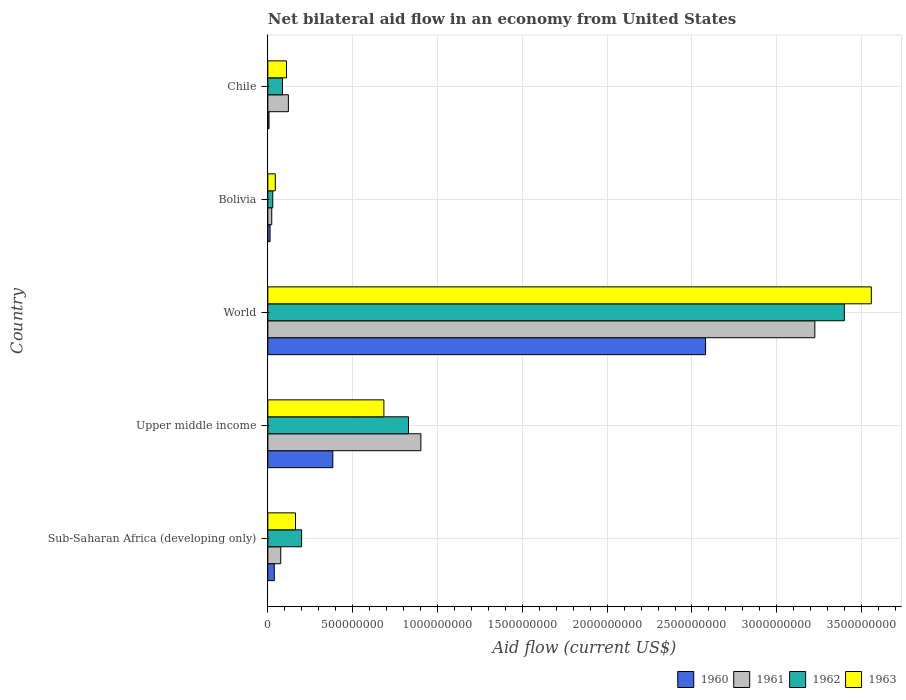How many groups of bars are there?
Keep it short and to the point. 5. Are the number of bars on each tick of the Y-axis equal?
Your answer should be compact. Yes. What is the label of the 3rd group of bars from the top?
Your answer should be very brief. World. In how many cases, is the number of bars for a given country not equal to the number of legend labels?
Give a very brief answer. 0. What is the net bilateral aid flow in 1963 in Upper middle income?
Your answer should be compact. 6.84e+08. Across all countries, what is the maximum net bilateral aid flow in 1960?
Give a very brief answer. 2.58e+09. What is the total net bilateral aid flow in 1960 in the graph?
Ensure brevity in your answer.  3.02e+09. What is the difference between the net bilateral aid flow in 1961 in Bolivia and that in Chile?
Make the answer very short. -9.80e+07. What is the difference between the net bilateral aid flow in 1960 in Bolivia and the net bilateral aid flow in 1961 in Sub-Saharan Africa (developing only)?
Your response must be concise. -6.30e+07. What is the average net bilateral aid flow in 1960 per country?
Give a very brief answer. 6.04e+08. What is the difference between the net bilateral aid flow in 1960 and net bilateral aid flow in 1963 in Sub-Saharan Africa (developing only)?
Provide a succinct answer. -1.25e+08. What is the ratio of the net bilateral aid flow in 1960 in Chile to that in World?
Provide a succinct answer. 0. Is the net bilateral aid flow in 1960 in Chile less than that in Upper middle income?
Offer a terse response. Yes. Is the difference between the net bilateral aid flow in 1960 in Sub-Saharan Africa (developing only) and Upper middle income greater than the difference between the net bilateral aid flow in 1963 in Sub-Saharan Africa (developing only) and Upper middle income?
Your response must be concise. Yes. What is the difference between the highest and the second highest net bilateral aid flow in 1961?
Your response must be concise. 2.32e+09. What is the difference between the highest and the lowest net bilateral aid flow in 1960?
Keep it short and to the point. 2.57e+09. In how many countries, is the net bilateral aid flow in 1960 greater than the average net bilateral aid flow in 1960 taken over all countries?
Give a very brief answer. 1. Is it the case that in every country, the sum of the net bilateral aid flow in 1962 and net bilateral aid flow in 1963 is greater than the sum of net bilateral aid flow in 1961 and net bilateral aid flow in 1960?
Ensure brevity in your answer.  No. Is it the case that in every country, the sum of the net bilateral aid flow in 1960 and net bilateral aid flow in 1963 is greater than the net bilateral aid flow in 1962?
Make the answer very short. Yes. How many bars are there?
Your answer should be compact. 20. Are all the bars in the graph horizontal?
Your response must be concise. Yes. Does the graph contain any zero values?
Ensure brevity in your answer.  No. Does the graph contain grids?
Offer a very short reply. Yes. How many legend labels are there?
Offer a very short reply. 4. How are the legend labels stacked?
Offer a terse response. Horizontal. What is the title of the graph?
Your response must be concise. Net bilateral aid flow in an economy from United States. Does "1962" appear as one of the legend labels in the graph?
Keep it short and to the point. Yes. What is the label or title of the Y-axis?
Give a very brief answer. Country. What is the Aid flow (current US$) of 1960 in Sub-Saharan Africa (developing only)?
Provide a short and direct response. 3.80e+07. What is the Aid flow (current US$) of 1961 in Sub-Saharan Africa (developing only)?
Offer a very short reply. 7.60e+07. What is the Aid flow (current US$) of 1962 in Sub-Saharan Africa (developing only)?
Your response must be concise. 1.99e+08. What is the Aid flow (current US$) in 1963 in Sub-Saharan Africa (developing only)?
Ensure brevity in your answer.  1.63e+08. What is the Aid flow (current US$) of 1960 in Upper middle income?
Offer a very short reply. 3.83e+08. What is the Aid flow (current US$) of 1961 in Upper middle income?
Offer a terse response. 9.02e+08. What is the Aid flow (current US$) of 1962 in Upper middle income?
Provide a short and direct response. 8.29e+08. What is the Aid flow (current US$) in 1963 in Upper middle income?
Give a very brief answer. 6.84e+08. What is the Aid flow (current US$) of 1960 in World?
Your response must be concise. 2.58e+09. What is the Aid flow (current US$) of 1961 in World?
Make the answer very short. 3.22e+09. What is the Aid flow (current US$) of 1962 in World?
Your response must be concise. 3.40e+09. What is the Aid flow (current US$) in 1963 in World?
Your response must be concise. 3.56e+09. What is the Aid flow (current US$) of 1960 in Bolivia?
Provide a short and direct response. 1.30e+07. What is the Aid flow (current US$) of 1961 in Bolivia?
Your answer should be very brief. 2.30e+07. What is the Aid flow (current US$) of 1962 in Bolivia?
Ensure brevity in your answer.  2.90e+07. What is the Aid flow (current US$) in 1963 in Bolivia?
Provide a short and direct response. 4.40e+07. What is the Aid flow (current US$) of 1960 in Chile?
Provide a short and direct response. 7.00e+06. What is the Aid flow (current US$) of 1961 in Chile?
Provide a short and direct response. 1.21e+08. What is the Aid flow (current US$) in 1962 in Chile?
Keep it short and to the point. 8.60e+07. What is the Aid flow (current US$) of 1963 in Chile?
Provide a succinct answer. 1.10e+08. Across all countries, what is the maximum Aid flow (current US$) of 1960?
Keep it short and to the point. 2.58e+09. Across all countries, what is the maximum Aid flow (current US$) in 1961?
Give a very brief answer. 3.22e+09. Across all countries, what is the maximum Aid flow (current US$) in 1962?
Provide a short and direct response. 3.40e+09. Across all countries, what is the maximum Aid flow (current US$) of 1963?
Provide a short and direct response. 3.56e+09. Across all countries, what is the minimum Aid flow (current US$) of 1961?
Keep it short and to the point. 2.30e+07. Across all countries, what is the minimum Aid flow (current US$) in 1962?
Offer a terse response. 2.90e+07. Across all countries, what is the minimum Aid flow (current US$) in 1963?
Provide a short and direct response. 4.40e+07. What is the total Aid flow (current US$) in 1960 in the graph?
Your response must be concise. 3.02e+09. What is the total Aid flow (current US$) in 1961 in the graph?
Provide a succinct answer. 4.35e+09. What is the total Aid flow (current US$) of 1962 in the graph?
Make the answer very short. 4.54e+09. What is the total Aid flow (current US$) of 1963 in the graph?
Your answer should be very brief. 4.56e+09. What is the difference between the Aid flow (current US$) of 1960 in Sub-Saharan Africa (developing only) and that in Upper middle income?
Ensure brevity in your answer.  -3.45e+08. What is the difference between the Aid flow (current US$) of 1961 in Sub-Saharan Africa (developing only) and that in Upper middle income?
Your response must be concise. -8.26e+08. What is the difference between the Aid flow (current US$) of 1962 in Sub-Saharan Africa (developing only) and that in Upper middle income?
Your response must be concise. -6.30e+08. What is the difference between the Aid flow (current US$) in 1963 in Sub-Saharan Africa (developing only) and that in Upper middle income?
Keep it short and to the point. -5.21e+08. What is the difference between the Aid flow (current US$) of 1960 in Sub-Saharan Africa (developing only) and that in World?
Ensure brevity in your answer.  -2.54e+09. What is the difference between the Aid flow (current US$) of 1961 in Sub-Saharan Africa (developing only) and that in World?
Make the answer very short. -3.15e+09. What is the difference between the Aid flow (current US$) in 1962 in Sub-Saharan Africa (developing only) and that in World?
Your answer should be compact. -3.20e+09. What is the difference between the Aid flow (current US$) in 1963 in Sub-Saharan Africa (developing only) and that in World?
Offer a very short reply. -3.39e+09. What is the difference between the Aid flow (current US$) in 1960 in Sub-Saharan Africa (developing only) and that in Bolivia?
Make the answer very short. 2.50e+07. What is the difference between the Aid flow (current US$) of 1961 in Sub-Saharan Africa (developing only) and that in Bolivia?
Keep it short and to the point. 5.30e+07. What is the difference between the Aid flow (current US$) in 1962 in Sub-Saharan Africa (developing only) and that in Bolivia?
Provide a succinct answer. 1.70e+08. What is the difference between the Aid flow (current US$) of 1963 in Sub-Saharan Africa (developing only) and that in Bolivia?
Your response must be concise. 1.19e+08. What is the difference between the Aid flow (current US$) of 1960 in Sub-Saharan Africa (developing only) and that in Chile?
Ensure brevity in your answer.  3.10e+07. What is the difference between the Aid flow (current US$) in 1961 in Sub-Saharan Africa (developing only) and that in Chile?
Ensure brevity in your answer.  -4.50e+07. What is the difference between the Aid flow (current US$) in 1962 in Sub-Saharan Africa (developing only) and that in Chile?
Your answer should be very brief. 1.13e+08. What is the difference between the Aid flow (current US$) of 1963 in Sub-Saharan Africa (developing only) and that in Chile?
Your answer should be very brief. 5.30e+07. What is the difference between the Aid flow (current US$) of 1960 in Upper middle income and that in World?
Your answer should be compact. -2.20e+09. What is the difference between the Aid flow (current US$) of 1961 in Upper middle income and that in World?
Ensure brevity in your answer.  -2.32e+09. What is the difference between the Aid flow (current US$) in 1962 in Upper middle income and that in World?
Your answer should be very brief. -2.57e+09. What is the difference between the Aid flow (current US$) in 1963 in Upper middle income and that in World?
Give a very brief answer. -2.87e+09. What is the difference between the Aid flow (current US$) in 1960 in Upper middle income and that in Bolivia?
Offer a terse response. 3.70e+08. What is the difference between the Aid flow (current US$) of 1961 in Upper middle income and that in Bolivia?
Your response must be concise. 8.79e+08. What is the difference between the Aid flow (current US$) of 1962 in Upper middle income and that in Bolivia?
Make the answer very short. 8.00e+08. What is the difference between the Aid flow (current US$) of 1963 in Upper middle income and that in Bolivia?
Provide a succinct answer. 6.40e+08. What is the difference between the Aid flow (current US$) of 1960 in Upper middle income and that in Chile?
Your response must be concise. 3.76e+08. What is the difference between the Aid flow (current US$) of 1961 in Upper middle income and that in Chile?
Offer a terse response. 7.81e+08. What is the difference between the Aid flow (current US$) of 1962 in Upper middle income and that in Chile?
Give a very brief answer. 7.43e+08. What is the difference between the Aid flow (current US$) of 1963 in Upper middle income and that in Chile?
Give a very brief answer. 5.74e+08. What is the difference between the Aid flow (current US$) in 1960 in World and that in Bolivia?
Offer a very short reply. 2.57e+09. What is the difference between the Aid flow (current US$) of 1961 in World and that in Bolivia?
Provide a short and direct response. 3.20e+09. What is the difference between the Aid flow (current US$) of 1962 in World and that in Bolivia?
Your response must be concise. 3.37e+09. What is the difference between the Aid flow (current US$) of 1963 in World and that in Bolivia?
Provide a short and direct response. 3.51e+09. What is the difference between the Aid flow (current US$) of 1960 in World and that in Chile?
Ensure brevity in your answer.  2.57e+09. What is the difference between the Aid flow (current US$) in 1961 in World and that in Chile?
Make the answer very short. 3.10e+09. What is the difference between the Aid flow (current US$) of 1962 in World and that in Chile?
Your answer should be very brief. 3.31e+09. What is the difference between the Aid flow (current US$) in 1963 in World and that in Chile?
Your response must be concise. 3.45e+09. What is the difference between the Aid flow (current US$) of 1960 in Bolivia and that in Chile?
Offer a terse response. 6.00e+06. What is the difference between the Aid flow (current US$) in 1961 in Bolivia and that in Chile?
Keep it short and to the point. -9.80e+07. What is the difference between the Aid flow (current US$) of 1962 in Bolivia and that in Chile?
Offer a very short reply. -5.70e+07. What is the difference between the Aid flow (current US$) of 1963 in Bolivia and that in Chile?
Offer a very short reply. -6.60e+07. What is the difference between the Aid flow (current US$) of 1960 in Sub-Saharan Africa (developing only) and the Aid flow (current US$) of 1961 in Upper middle income?
Offer a terse response. -8.64e+08. What is the difference between the Aid flow (current US$) of 1960 in Sub-Saharan Africa (developing only) and the Aid flow (current US$) of 1962 in Upper middle income?
Keep it short and to the point. -7.91e+08. What is the difference between the Aid flow (current US$) of 1960 in Sub-Saharan Africa (developing only) and the Aid flow (current US$) of 1963 in Upper middle income?
Offer a terse response. -6.46e+08. What is the difference between the Aid flow (current US$) in 1961 in Sub-Saharan Africa (developing only) and the Aid flow (current US$) in 1962 in Upper middle income?
Provide a short and direct response. -7.53e+08. What is the difference between the Aid flow (current US$) in 1961 in Sub-Saharan Africa (developing only) and the Aid flow (current US$) in 1963 in Upper middle income?
Your answer should be compact. -6.08e+08. What is the difference between the Aid flow (current US$) in 1962 in Sub-Saharan Africa (developing only) and the Aid flow (current US$) in 1963 in Upper middle income?
Provide a short and direct response. -4.85e+08. What is the difference between the Aid flow (current US$) of 1960 in Sub-Saharan Africa (developing only) and the Aid flow (current US$) of 1961 in World?
Your answer should be very brief. -3.19e+09. What is the difference between the Aid flow (current US$) in 1960 in Sub-Saharan Africa (developing only) and the Aid flow (current US$) in 1962 in World?
Your response must be concise. -3.36e+09. What is the difference between the Aid flow (current US$) of 1960 in Sub-Saharan Africa (developing only) and the Aid flow (current US$) of 1963 in World?
Offer a very short reply. -3.52e+09. What is the difference between the Aid flow (current US$) of 1961 in Sub-Saharan Africa (developing only) and the Aid flow (current US$) of 1962 in World?
Ensure brevity in your answer.  -3.32e+09. What is the difference between the Aid flow (current US$) of 1961 in Sub-Saharan Africa (developing only) and the Aid flow (current US$) of 1963 in World?
Provide a succinct answer. -3.48e+09. What is the difference between the Aid flow (current US$) of 1962 in Sub-Saharan Africa (developing only) and the Aid flow (current US$) of 1963 in World?
Provide a succinct answer. -3.36e+09. What is the difference between the Aid flow (current US$) in 1960 in Sub-Saharan Africa (developing only) and the Aid flow (current US$) in 1961 in Bolivia?
Give a very brief answer. 1.50e+07. What is the difference between the Aid flow (current US$) in 1960 in Sub-Saharan Africa (developing only) and the Aid flow (current US$) in 1962 in Bolivia?
Your answer should be very brief. 9.00e+06. What is the difference between the Aid flow (current US$) of 1960 in Sub-Saharan Africa (developing only) and the Aid flow (current US$) of 1963 in Bolivia?
Keep it short and to the point. -6.00e+06. What is the difference between the Aid flow (current US$) in 1961 in Sub-Saharan Africa (developing only) and the Aid flow (current US$) in 1962 in Bolivia?
Your response must be concise. 4.70e+07. What is the difference between the Aid flow (current US$) of 1961 in Sub-Saharan Africa (developing only) and the Aid flow (current US$) of 1963 in Bolivia?
Make the answer very short. 3.20e+07. What is the difference between the Aid flow (current US$) of 1962 in Sub-Saharan Africa (developing only) and the Aid flow (current US$) of 1963 in Bolivia?
Make the answer very short. 1.55e+08. What is the difference between the Aid flow (current US$) of 1960 in Sub-Saharan Africa (developing only) and the Aid flow (current US$) of 1961 in Chile?
Your response must be concise. -8.30e+07. What is the difference between the Aid flow (current US$) of 1960 in Sub-Saharan Africa (developing only) and the Aid flow (current US$) of 1962 in Chile?
Offer a very short reply. -4.80e+07. What is the difference between the Aid flow (current US$) in 1960 in Sub-Saharan Africa (developing only) and the Aid flow (current US$) in 1963 in Chile?
Your response must be concise. -7.20e+07. What is the difference between the Aid flow (current US$) in 1961 in Sub-Saharan Africa (developing only) and the Aid flow (current US$) in 1962 in Chile?
Provide a succinct answer. -1.00e+07. What is the difference between the Aid flow (current US$) in 1961 in Sub-Saharan Africa (developing only) and the Aid flow (current US$) in 1963 in Chile?
Offer a very short reply. -3.40e+07. What is the difference between the Aid flow (current US$) of 1962 in Sub-Saharan Africa (developing only) and the Aid flow (current US$) of 1963 in Chile?
Offer a very short reply. 8.90e+07. What is the difference between the Aid flow (current US$) in 1960 in Upper middle income and the Aid flow (current US$) in 1961 in World?
Provide a succinct answer. -2.84e+09. What is the difference between the Aid flow (current US$) in 1960 in Upper middle income and the Aid flow (current US$) in 1962 in World?
Keep it short and to the point. -3.02e+09. What is the difference between the Aid flow (current US$) in 1960 in Upper middle income and the Aid flow (current US$) in 1963 in World?
Your response must be concise. -3.17e+09. What is the difference between the Aid flow (current US$) of 1961 in Upper middle income and the Aid flow (current US$) of 1962 in World?
Ensure brevity in your answer.  -2.50e+09. What is the difference between the Aid flow (current US$) of 1961 in Upper middle income and the Aid flow (current US$) of 1963 in World?
Offer a very short reply. -2.66e+09. What is the difference between the Aid flow (current US$) of 1962 in Upper middle income and the Aid flow (current US$) of 1963 in World?
Keep it short and to the point. -2.73e+09. What is the difference between the Aid flow (current US$) of 1960 in Upper middle income and the Aid flow (current US$) of 1961 in Bolivia?
Your answer should be very brief. 3.60e+08. What is the difference between the Aid flow (current US$) of 1960 in Upper middle income and the Aid flow (current US$) of 1962 in Bolivia?
Give a very brief answer. 3.54e+08. What is the difference between the Aid flow (current US$) in 1960 in Upper middle income and the Aid flow (current US$) in 1963 in Bolivia?
Provide a short and direct response. 3.39e+08. What is the difference between the Aid flow (current US$) in 1961 in Upper middle income and the Aid flow (current US$) in 1962 in Bolivia?
Your answer should be compact. 8.73e+08. What is the difference between the Aid flow (current US$) of 1961 in Upper middle income and the Aid flow (current US$) of 1963 in Bolivia?
Keep it short and to the point. 8.58e+08. What is the difference between the Aid flow (current US$) of 1962 in Upper middle income and the Aid flow (current US$) of 1963 in Bolivia?
Your answer should be very brief. 7.85e+08. What is the difference between the Aid flow (current US$) in 1960 in Upper middle income and the Aid flow (current US$) in 1961 in Chile?
Give a very brief answer. 2.62e+08. What is the difference between the Aid flow (current US$) in 1960 in Upper middle income and the Aid flow (current US$) in 1962 in Chile?
Provide a short and direct response. 2.97e+08. What is the difference between the Aid flow (current US$) of 1960 in Upper middle income and the Aid flow (current US$) of 1963 in Chile?
Offer a terse response. 2.73e+08. What is the difference between the Aid flow (current US$) in 1961 in Upper middle income and the Aid flow (current US$) in 1962 in Chile?
Your response must be concise. 8.16e+08. What is the difference between the Aid flow (current US$) of 1961 in Upper middle income and the Aid flow (current US$) of 1963 in Chile?
Ensure brevity in your answer.  7.92e+08. What is the difference between the Aid flow (current US$) of 1962 in Upper middle income and the Aid flow (current US$) of 1963 in Chile?
Your answer should be very brief. 7.19e+08. What is the difference between the Aid flow (current US$) of 1960 in World and the Aid flow (current US$) of 1961 in Bolivia?
Your answer should be compact. 2.56e+09. What is the difference between the Aid flow (current US$) of 1960 in World and the Aid flow (current US$) of 1962 in Bolivia?
Offer a very short reply. 2.55e+09. What is the difference between the Aid flow (current US$) of 1960 in World and the Aid flow (current US$) of 1963 in Bolivia?
Your answer should be very brief. 2.54e+09. What is the difference between the Aid flow (current US$) of 1961 in World and the Aid flow (current US$) of 1962 in Bolivia?
Your answer should be very brief. 3.20e+09. What is the difference between the Aid flow (current US$) in 1961 in World and the Aid flow (current US$) in 1963 in Bolivia?
Provide a short and direct response. 3.18e+09. What is the difference between the Aid flow (current US$) of 1962 in World and the Aid flow (current US$) of 1963 in Bolivia?
Provide a short and direct response. 3.35e+09. What is the difference between the Aid flow (current US$) of 1960 in World and the Aid flow (current US$) of 1961 in Chile?
Offer a very short reply. 2.46e+09. What is the difference between the Aid flow (current US$) of 1960 in World and the Aid flow (current US$) of 1962 in Chile?
Ensure brevity in your answer.  2.49e+09. What is the difference between the Aid flow (current US$) of 1960 in World and the Aid flow (current US$) of 1963 in Chile?
Provide a succinct answer. 2.47e+09. What is the difference between the Aid flow (current US$) of 1961 in World and the Aid flow (current US$) of 1962 in Chile?
Keep it short and to the point. 3.14e+09. What is the difference between the Aid flow (current US$) of 1961 in World and the Aid flow (current US$) of 1963 in Chile?
Your answer should be compact. 3.11e+09. What is the difference between the Aid flow (current US$) in 1962 in World and the Aid flow (current US$) in 1963 in Chile?
Offer a terse response. 3.29e+09. What is the difference between the Aid flow (current US$) in 1960 in Bolivia and the Aid flow (current US$) in 1961 in Chile?
Make the answer very short. -1.08e+08. What is the difference between the Aid flow (current US$) in 1960 in Bolivia and the Aid flow (current US$) in 1962 in Chile?
Keep it short and to the point. -7.30e+07. What is the difference between the Aid flow (current US$) in 1960 in Bolivia and the Aid flow (current US$) in 1963 in Chile?
Keep it short and to the point. -9.70e+07. What is the difference between the Aid flow (current US$) in 1961 in Bolivia and the Aid flow (current US$) in 1962 in Chile?
Make the answer very short. -6.30e+07. What is the difference between the Aid flow (current US$) of 1961 in Bolivia and the Aid flow (current US$) of 1963 in Chile?
Keep it short and to the point. -8.70e+07. What is the difference between the Aid flow (current US$) in 1962 in Bolivia and the Aid flow (current US$) in 1963 in Chile?
Provide a short and direct response. -8.10e+07. What is the average Aid flow (current US$) of 1960 per country?
Your response must be concise. 6.04e+08. What is the average Aid flow (current US$) of 1961 per country?
Keep it short and to the point. 8.69e+08. What is the average Aid flow (current US$) of 1962 per country?
Make the answer very short. 9.08e+08. What is the average Aid flow (current US$) in 1963 per country?
Provide a succinct answer. 9.12e+08. What is the difference between the Aid flow (current US$) in 1960 and Aid flow (current US$) in 1961 in Sub-Saharan Africa (developing only)?
Ensure brevity in your answer.  -3.80e+07. What is the difference between the Aid flow (current US$) of 1960 and Aid flow (current US$) of 1962 in Sub-Saharan Africa (developing only)?
Ensure brevity in your answer.  -1.61e+08. What is the difference between the Aid flow (current US$) of 1960 and Aid flow (current US$) of 1963 in Sub-Saharan Africa (developing only)?
Ensure brevity in your answer.  -1.25e+08. What is the difference between the Aid flow (current US$) of 1961 and Aid flow (current US$) of 1962 in Sub-Saharan Africa (developing only)?
Keep it short and to the point. -1.23e+08. What is the difference between the Aid flow (current US$) in 1961 and Aid flow (current US$) in 1963 in Sub-Saharan Africa (developing only)?
Your response must be concise. -8.70e+07. What is the difference between the Aid flow (current US$) of 1962 and Aid flow (current US$) of 1963 in Sub-Saharan Africa (developing only)?
Offer a terse response. 3.60e+07. What is the difference between the Aid flow (current US$) of 1960 and Aid flow (current US$) of 1961 in Upper middle income?
Offer a terse response. -5.19e+08. What is the difference between the Aid flow (current US$) of 1960 and Aid flow (current US$) of 1962 in Upper middle income?
Make the answer very short. -4.46e+08. What is the difference between the Aid flow (current US$) of 1960 and Aid flow (current US$) of 1963 in Upper middle income?
Your answer should be very brief. -3.01e+08. What is the difference between the Aid flow (current US$) of 1961 and Aid flow (current US$) of 1962 in Upper middle income?
Ensure brevity in your answer.  7.30e+07. What is the difference between the Aid flow (current US$) of 1961 and Aid flow (current US$) of 1963 in Upper middle income?
Provide a succinct answer. 2.18e+08. What is the difference between the Aid flow (current US$) in 1962 and Aid flow (current US$) in 1963 in Upper middle income?
Your answer should be compact. 1.45e+08. What is the difference between the Aid flow (current US$) of 1960 and Aid flow (current US$) of 1961 in World?
Make the answer very short. -6.44e+08. What is the difference between the Aid flow (current US$) in 1960 and Aid flow (current US$) in 1962 in World?
Offer a very short reply. -8.18e+08. What is the difference between the Aid flow (current US$) in 1960 and Aid flow (current US$) in 1963 in World?
Give a very brief answer. -9.77e+08. What is the difference between the Aid flow (current US$) in 1961 and Aid flow (current US$) in 1962 in World?
Provide a succinct answer. -1.74e+08. What is the difference between the Aid flow (current US$) in 1961 and Aid flow (current US$) in 1963 in World?
Provide a succinct answer. -3.33e+08. What is the difference between the Aid flow (current US$) of 1962 and Aid flow (current US$) of 1963 in World?
Provide a short and direct response. -1.59e+08. What is the difference between the Aid flow (current US$) in 1960 and Aid flow (current US$) in 1961 in Bolivia?
Provide a succinct answer. -1.00e+07. What is the difference between the Aid flow (current US$) in 1960 and Aid flow (current US$) in 1962 in Bolivia?
Your response must be concise. -1.60e+07. What is the difference between the Aid flow (current US$) of 1960 and Aid flow (current US$) of 1963 in Bolivia?
Your answer should be compact. -3.10e+07. What is the difference between the Aid flow (current US$) of 1961 and Aid flow (current US$) of 1962 in Bolivia?
Provide a short and direct response. -6.00e+06. What is the difference between the Aid flow (current US$) in 1961 and Aid flow (current US$) in 1963 in Bolivia?
Your answer should be compact. -2.10e+07. What is the difference between the Aid flow (current US$) in 1962 and Aid flow (current US$) in 1963 in Bolivia?
Give a very brief answer. -1.50e+07. What is the difference between the Aid flow (current US$) of 1960 and Aid flow (current US$) of 1961 in Chile?
Ensure brevity in your answer.  -1.14e+08. What is the difference between the Aid flow (current US$) in 1960 and Aid flow (current US$) in 1962 in Chile?
Your answer should be very brief. -7.90e+07. What is the difference between the Aid flow (current US$) in 1960 and Aid flow (current US$) in 1963 in Chile?
Ensure brevity in your answer.  -1.03e+08. What is the difference between the Aid flow (current US$) of 1961 and Aid flow (current US$) of 1962 in Chile?
Provide a succinct answer. 3.50e+07. What is the difference between the Aid flow (current US$) of 1961 and Aid flow (current US$) of 1963 in Chile?
Provide a succinct answer. 1.10e+07. What is the difference between the Aid flow (current US$) of 1962 and Aid flow (current US$) of 1963 in Chile?
Offer a very short reply. -2.40e+07. What is the ratio of the Aid flow (current US$) in 1960 in Sub-Saharan Africa (developing only) to that in Upper middle income?
Offer a terse response. 0.1. What is the ratio of the Aid flow (current US$) in 1961 in Sub-Saharan Africa (developing only) to that in Upper middle income?
Provide a succinct answer. 0.08. What is the ratio of the Aid flow (current US$) in 1962 in Sub-Saharan Africa (developing only) to that in Upper middle income?
Make the answer very short. 0.24. What is the ratio of the Aid flow (current US$) in 1963 in Sub-Saharan Africa (developing only) to that in Upper middle income?
Your response must be concise. 0.24. What is the ratio of the Aid flow (current US$) of 1960 in Sub-Saharan Africa (developing only) to that in World?
Provide a succinct answer. 0.01. What is the ratio of the Aid flow (current US$) in 1961 in Sub-Saharan Africa (developing only) to that in World?
Keep it short and to the point. 0.02. What is the ratio of the Aid flow (current US$) in 1962 in Sub-Saharan Africa (developing only) to that in World?
Your response must be concise. 0.06. What is the ratio of the Aid flow (current US$) of 1963 in Sub-Saharan Africa (developing only) to that in World?
Make the answer very short. 0.05. What is the ratio of the Aid flow (current US$) in 1960 in Sub-Saharan Africa (developing only) to that in Bolivia?
Give a very brief answer. 2.92. What is the ratio of the Aid flow (current US$) in 1961 in Sub-Saharan Africa (developing only) to that in Bolivia?
Make the answer very short. 3.3. What is the ratio of the Aid flow (current US$) in 1962 in Sub-Saharan Africa (developing only) to that in Bolivia?
Your response must be concise. 6.86. What is the ratio of the Aid flow (current US$) in 1963 in Sub-Saharan Africa (developing only) to that in Bolivia?
Make the answer very short. 3.7. What is the ratio of the Aid flow (current US$) in 1960 in Sub-Saharan Africa (developing only) to that in Chile?
Your response must be concise. 5.43. What is the ratio of the Aid flow (current US$) in 1961 in Sub-Saharan Africa (developing only) to that in Chile?
Keep it short and to the point. 0.63. What is the ratio of the Aid flow (current US$) of 1962 in Sub-Saharan Africa (developing only) to that in Chile?
Offer a very short reply. 2.31. What is the ratio of the Aid flow (current US$) of 1963 in Sub-Saharan Africa (developing only) to that in Chile?
Give a very brief answer. 1.48. What is the ratio of the Aid flow (current US$) of 1960 in Upper middle income to that in World?
Ensure brevity in your answer.  0.15. What is the ratio of the Aid flow (current US$) of 1961 in Upper middle income to that in World?
Your answer should be very brief. 0.28. What is the ratio of the Aid flow (current US$) in 1962 in Upper middle income to that in World?
Your answer should be compact. 0.24. What is the ratio of the Aid flow (current US$) of 1963 in Upper middle income to that in World?
Give a very brief answer. 0.19. What is the ratio of the Aid flow (current US$) of 1960 in Upper middle income to that in Bolivia?
Provide a succinct answer. 29.46. What is the ratio of the Aid flow (current US$) of 1961 in Upper middle income to that in Bolivia?
Your response must be concise. 39.22. What is the ratio of the Aid flow (current US$) in 1962 in Upper middle income to that in Bolivia?
Give a very brief answer. 28.59. What is the ratio of the Aid flow (current US$) in 1963 in Upper middle income to that in Bolivia?
Offer a very short reply. 15.55. What is the ratio of the Aid flow (current US$) of 1960 in Upper middle income to that in Chile?
Your response must be concise. 54.71. What is the ratio of the Aid flow (current US$) in 1961 in Upper middle income to that in Chile?
Keep it short and to the point. 7.45. What is the ratio of the Aid flow (current US$) of 1962 in Upper middle income to that in Chile?
Offer a very short reply. 9.64. What is the ratio of the Aid flow (current US$) of 1963 in Upper middle income to that in Chile?
Offer a terse response. 6.22. What is the ratio of the Aid flow (current US$) in 1960 in World to that in Bolivia?
Keep it short and to the point. 198.46. What is the ratio of the Aid flow (current US$) in 1961 in World to that in Bolivia?
Your answer should be compact. 140.17. What is the ratio of the Aid flow (current US$) of 1962 in World to that in Bolivia?
Provide a short and direct response. 117.17. What is the ratio of the Aid flow (current US$) in 1963 in World to that in Bolivia?
Provide a short and direct response. 80.84. What is the ratio of the Aid flow (current US$) in 1960 in World to that in Chile?
Offer a terse response. 368.57. What is the ratio of the Aid flow (current US$) of 1961 in World to that in Chile?
Make the answer very short. 26.64. What is the ratio of the Aid flow (current US$) in 1962 in World to that in Chile?
Offer a very short reply. 39.51. What is the ratio of the Aid flow (current US$) in 1963 in World to that in Chile?
Give a very brief answer. 32.34. What is the ratio of the Aid flow (current US$) in 1960 in Bolivia to that in Chile?
Your answer should be compact. 1.86. What is the ratio of the Aid flow (current US$) of 1961 in Bolivia to that in Chile?
Offer a very short reply. 0.19. What is the ratio of the Aid flow (current US$) in 1962 in Bolivia to that in Chile?
Your response must be concise. 0.34. What is the difference between the highest and the second highest Aid flow (current US$) in 1960?
Your response must be concise. 2.20e+09. What is the difference between the highest and the second highest Aid flow (current US$) of 1961?
Your answer should be very brief. 2.32e+09. What is the difference between the highest and the second highest Aid flow (current US$) in 1962?
Your answer should be compact. 2.57e+09. What is the difference between the highest and the second highest Aid flow (current US$) of 1963?
Offer a very short reply. 2.87e+09. What is the difference between the highest and the lowest Aid flow (current US$) in 1960?
Offer a terse response. 2.57e+09. What is the difference between the highest and the lowest Aid flow (current US$) of 1961?
Provide a short and direct response. 3.20e+09. What is the difference between the highest and the lowest Aid flow (current US$) of 1962?
Provide a succinct answer. 3.37e+09. What is the difference between the highest and the lowest Aid flow (current US$) in 1963?
Your response must be concise. 3.51e+09. 